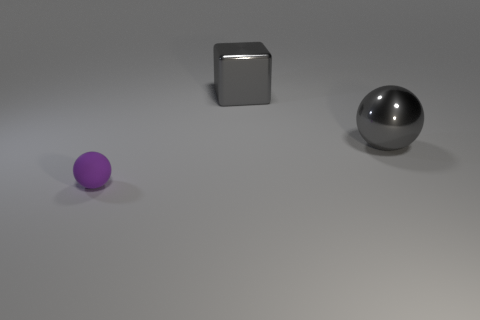Add 1 gray spheres. How many objects exist? 4 Subtract all spheres. How many objects are left? 1 Subtract 0 green balls. How many objects are left? 3 Subtract all purple things. Subtract all large gray metal spheres. How many objects are left? 1 Add 1 large metallic objects. How many large metallic objects are left? 3 Add 1 cyan blocks. How many cyan blocks exist? 1 